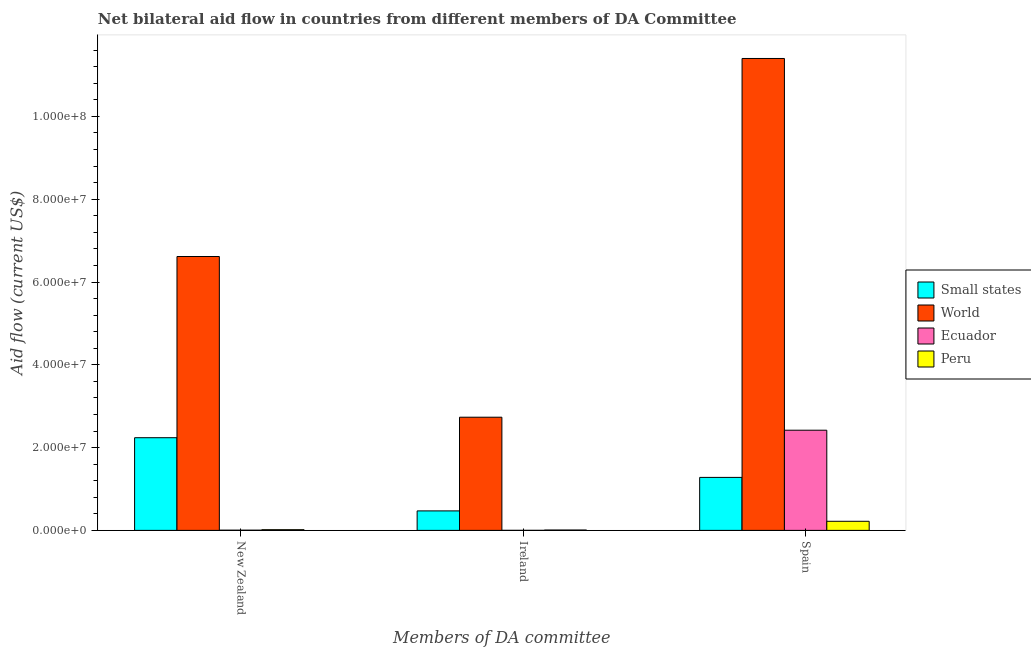Are the number of bars per tick equal to the number of legend labels?
Keep it short and to the point. Yes. Are the number of bars on each tick of the X-axis equal?
Provide a short and direct response. Yes. What is the label of the 2nd group of bars from the left?
Make the answer very short. Ireland. What is the amount of aid provided by ireland in Ecuador?
Offer a very short reply. 10000. Across all countries, what is the maximum amount of aid provided by spain?
Make the answer very short. 1.14e+08. Across all countries, what is the minimum amount of aid provided by ireland?
Your answer should be very brief. 10000. In which country was the amount of aid provided by new zealand maximum?
Keep it short and to the point. World. In which country was the amount of aid provided by new zealand minimum?
Ensure brevity in your answer.  Ecuador. What is the total amount of aid provided by spain in the graph?
Keep it short and to the point. 1.53e+08. What is the difference between the amount of aid provided by new zealand in Peru and that in World?
Your response must be concise. -6.60e+07. What is the difference between the amount of aid provided by new zealand in World and the amount of aid provided by ireland in Small states?
Offer a very short reply. 6.14e+07. What is the average amount of aid provided by spain per country?
Offer a terse response. 3.83e+07. What is the difference between the amount of aid provided by new zealand and amount of aid provided by spain in Peru?
Your answer should be compact. -2.03e+06. In how many countries, is the amount of aid provided by new zealand greater than 16000000 US$?
Your answer should be very brief. 2. What is the ratio of the amount of aid provided by new zealand in World to that in Peru?
Offer a terse response. 389.18. Is the amount of aid provided by spain in Peru less than that in Small states?
Keep it short and to the point. Yes. Is the difference between the amount of aid provided by spain in World and Small states greater than the difference between the amount of aid provided by ireland in World and Small states?
Your answer should be very brief. Yes. What is the difference between the highest and the second highest amount of aid provided by new zealand?
Ensure brevity in your answer.  4.38e+07. What is the difference between the highest and the lowest amount of aid provided by spain?
Make the answer very short. 1.12e+08. Is the sum of the amount of aid provided by ireland in Small states and Ecuador greater than the maximum amount of aid provided by new zealand across all countries?
Offer a very short reply. No. What does the 2nd bar from the left in Spain represents?
Offer a terse response. World. What does the 2nd bar from the right in New Zealand represents?
Ensure brevity in your answer.  Ecuador. How many bars are there?
Your answer should be compact. 12. Are all the bars in the graph horizontal?
Ensure brevity in your answer.  No. What is the difference between two consecutive major ticks on the Y-axis?
Offer a terse response. 2.00e+07. Are the values on the major ticks of Y-axis written in scientific E-notation?
Ensure brevity in your answer.  Yes. Where does the legend appear in the graph?
Provide a succinct answer. Center right. What is the title of the graph?
Your response must be concise. Net bilateral aid flow in countries from different members of DA Committee. What is the label or title of the X-axis?
Provide a short and direct response. Members of DA committee. What is the Aid flow (current US$) in Small states in New Zealand?
Your response must be concise. 2.24e+07. What is the Aid flow (current US$) of World in New Zealand?
Your response must be concise. 6.62e+07. What is the Aid flow (current US$) in Peru in New Zealand?
Ensure brevity in your answer.  1.70e+05. What is the Aid flow (current US$) in Small states in Ireland?
Give a very brief answer. 4.71e+06. What is the Aid flow (current US$) of World in Ireland?
Ensure brevity in your answer.  2.73e+07. What is the Aid flow (current US$) of Ecuador in Ireland?
Provide a short and direct response. 10000. What is the Aid flow (current US$) of Small states in Spain?
Offer a very short reply. 1.28e+07. What is the Aid flow (current US$) of World in Spain?
Make the answer very short. 1.14e+08. What is the Aid flow (current US$) of Ecuador in Spain?
Provide a short and direct response. 2.42e+07. What is the Aid flow (current US$) in Peru in Spain?
Your answer should be compact. 2.20e+06. Across all Members of DA committee, what is the maximum Aid flow (current US$) of Small states?
Provide a short and direct response. 2.24e+07. Across all Members of DA committee, what is the maximum Aid flow (current US$) of World?
Your answer should be very brief. 1.14e+08. Across all Members of DA committee, what is the maximum Aid flow (current US$) of Ecuador?
Ensure brevity in your answer.  2.42e+07. Across all Members of DA committee, what is the maximum Aid flow (current US$) in Peru?
Provide a succinct answer. 2.20e+06. Across all Members of DA committee, what is the minimum Aid flow (current US$) of Small states?
Offer a very short reply. 4.71e+06. Across all Members of DA committee, what is the minimum Aid flow (current US$) in World?
Your response must be concise. 2.73e+07. Across all Members of DA committee, what is the minimum Aid flow (current US$) of Peru?
Your answer should be compact. 9.00e+04. What is the total Aid flow (current US$) in Small states in the graph?
Provide a short and direct response. 3.99e+07. What is the total Aid flow (current US$) of World in the graph?
Ensure brevity in your answer.  2.08e+08. What is the total Aid flow (current US$) in Ecuador in the graph?
Your answer should be very brief. 2.43e+07. What is the total Aid flow (current US$) of Peru in the graph?
Provide a short and direct response. 2.46e+06. What is the difference between the Aid flow (current US$) of Small states in New Zealand and that in Ireland?
Keep it short and to the point. 1.77e+07. What is the difference between the Aid flow (current US$) of World in New Zealand and that in Ireland?
Provide a succinct answer. 3.88e+07. What is the difference between the Aid flow (current US$) of Peru in New Zealand and that in Ireland?
Offer a terse response. 8.00e+04. What is the difference between the Aid flow (current US$) of Small states in New Zealand and that in Spain?
Provide a succinct answer. 9.59e+06. What is the difference between the Aid flow (current US$) of World in New Zealand and that in Spain?
Provide a short and direct response. -4.78e+07. What is the difference between the Aid flow (current US$) of Ecuador in New Zealand and that in Spain?
Offer a very short reply. -2.42e+07. What is the difference between the Aid flow (current US$) of Peru in New Zealand and that in Spain?
Make the answer very short. -2.03e+06. What is the difference between the Aid flow (current US$) of Small states in Ireland and that in Spain?
Your answer should be compact. -8.09e+06. What is the difference between the Aid flow (current US$) of World in Ireland and that in Spain?
Offer a terse response. -8.67e+07. What is the difference between the Aid flow (current US$) in Ecuador in Ireland and that in Spain?
Make the answer very short. -2.42e+07. What is the difference between the Aid flow (current US$) in Peru in Ireland and that in Spain?
Give a very brief answer. -2.11e+06. What is the difference between the Aid flow (current US$) of Small states in New Zealand and the Aid flow (current US$) of World in Ireland?
Give a very brief answer. -4.95e+06. What is the difference between the Aid flow (current US$) of Small states in New Zealand and the Aid flow (current US$) of Ecuador in Ireland?
Give a very brief answer. 2.24e+07. What is the difference between the Aid flow (current US$) in Small states in New Zealand and the Aid flow (current US$) in Peru in Ireland?
Your answer should be very brief. 2.23e+07. What is the difference between the Aid flow (current US$) of World in New Zealand and the Aid flow (current US$) of Ecuador in Ireland?
Offer a very short reply. 6.62e+07. What is the difference between the Aid flow (current US$) in World in New Zealand and the Aid flow (current US$) in Peru in Ireland?
Ensure brevity in your answer.  6.61e+07. What is the difference between the Aid flow (current US$) of Ecuador in New Zealand and the Aid flow (current US$) of Peru in Ireland?
Provide a succinct answer. -4.00e+04. What is the difference between the Aid flow (current US$) in Small states in New Zealand and the Aid flow (current US$) in World in Spain?
Offer a very short reply. -9.16e+07. What is the difference between the Aid flow (current US$) of Small states in New Zealand and the Aid flow (current US$) of Ecuador in Spain?
Your answer should be very brief. -1.81e+06. What is the difference between the Aid flow (current US$) of Small states in New Zealand and the Aid flow (current US$) of Peru in Spain?
Give a very brief answer. 2.02e+07. What is the difference between the Aid flow (current US$) in World in New Zealand and the Aid flow (current US$) in Ecuador in Spain?
Give a very brief answer. 4.20e+07. What is the difference between the Aid flow (current US$) of World in New Zealand and the Aid flow (current US$) of Peru in Spain?
Offer a terse response. 6.40e+07. What is the difference between the Aid flow (current US$) in Ecuador in New Zealand and the Aid flow (current US$) in Peru in Spain?
Your answer should be compact. -2.15e+06. What is the difference between the Aid flow (current US$) of Small states in Ireland and the Aid flow (current US$) of World in Spain?
Offer a very short reply. -1.09e+08. What is the difference between the Aid flow (current US$) in Small states in Ireland and the Aid flow (current US$) in Ecuador in Spain?
Your answer should be compact. -1.95e+07. What is the difference between the Aid flow (current US$) in Small states in Ireland and the Aid flow (current US$) in Peru in Spain?
Give a very brief answer. 2.51e+06. What is the difference between the Aid flow (current US$) of World in Ireland and the Aid flow (current US$) of Ecuador in Spain?
Keep it short and to the point. 3.14e+06. What is the difference between the Aid flow (current US$) of World in Ireland and the Aid flow (current US$) of Peru in Spain?
Ensure brevity in your answer.  2.51e+07. What is the difference between the Aid flow (current US$) in Ecuador in Ireland and the Aid flow (current US$) in Peru in Spain?
Your response must be concise. -2.19e+06. What is the average Aid flow (current US$) of Small states per Members of DA committee?
Your response must be concise. 1.33e+07. What is the average Aid flow (current US$) of World per Members of DA committee?
Offer a terse response. 6.92e+07. What is the average Aid flow (current US$) of Ecuador per Members of DA committee?
Provide a short and direct response. 8.09e+06. What is the average Aid flow (current US$) in Peru per Members of DA committee?
Ensure brevity in your answer.  8.20e+05. What is the difference between the Aid flow (current US$) in Small states and Aid flow (current US$) in World in New Zealand?
Give a very brief answer. -4.38e+07. What is the difference between the Aid flow (current US$) in Small states and Aid flow (current US$) in Ecuador in New Zealand?
Provide a short and direct response. 2.23e+07. What is the difference between the Aid flow (current US$) in Small states and Aid flow (current US$) in Peru in New Zealand?
Make the answer very short. 2.22e+07. What is the difference between the Aid flow (current US$) in World and Aid flow (current US$) in Ecuador in New Zealand?
Provide a short and direct response. 6.61e+07. What is the difference between the Aid flow (current US$) in World and Aid flow (current US$) in Peru in New Zealand?
Provide a succinct answer. 6.60e+07. What is the difference between the Aid flow (current US$) in Small states and Aid flow (current US$) in World in Ireland?
Ensure brevity in your answer.  -2.26e+07. What is the difference between the Aid flow (current US$) of Small states and Aid flow (current US$) of Ecuador in Ireland?
Provide a succinct answer. 4.70e+06. What is the difference between the Aid flow (current US$) in Small states and Aid flow (current US$) in Peru in Ireland?
Ensure brevity in your answer.  4.62e+06. What is the difference between the Aid flow (current US$) in World and Aid flow (current US$) in Ecuador in Ireland?
Ensure brevity in your answer.  2.73e+07. What is the difference between the Aid flow (current US$) in World and Aid flow (current US$) in Peru in Ireland?
Offer a very short reply. 2.72e+07. What is the difference between the Aid flow (current US$) in Ecuador and Aid flow (current US$) in Peru in Ireland?
Your answer should be very brief. -8.00e+04. What is the difference between the Aid flow (current US$) in Small states and Aid flow (current US$) in World in Spain?
Your answer should be very brief. -1.01e+08. What is the difference between the Aid flow (current US$) of Small states and Aid flow (current US$) of Ecuador in Spain?
Your answer should be compact. -1.14e+07. What is the difference between the Aid flow (current US$) of Small states and Aid flow (current US$) of Peru in Spain?
Your response must be concise. 1.06e+07. What is the difference between the Aid flow (current US$) of World and Aid flow (current US$) of Ecuador in Spain?
Keep it short and to the point. 8.98e+07. What is the difference between the Aid flow (current US$) of World and Aid flow (current US$) of Peru in Spain?
Offer a very short reply. 1.12e+08. What is the difference between the Aid flow (current US$) of Ecuador and Aid flow (current US$) of Peru in Spain?
Keep it short and to the point. 2.20e+07. What is the ratio of the Aid flow (current US$) in Small states in New Zealand to that in Ireland?
Offer a very short reply. 4.75. What is the ratio of the Aid flow (current US$) of World in New Zealand to that in Ireland?
Provide a succinct answer. 2.42. What is the ratio of the Aid flow (current US$) in Ecuador in New Zealand to that in Ireland?
Give a very brief answer. 5. What is the ratio of the Aid flow (current US$) in Peru in New Zealand to that in Ireland?
Provide a succinct answer. 1.89. What is the ratio of the Aid flow (current US$) of Small states in New Zealand to that in Spain?
Make the answer very short. 1.75. What is the ratio of the Aid flow (current US$) in World in New Zealand to that in Spain?
Ensure brevity in your answer.  0.58. What is the ratio of the Aid flow (current US$) in Ecuador in New Zealand to that in Spain?
Make the answer very short. 0. What is the ratio of the Aid flow (current US$) in Peru in New Zealand to that in Spain?
Your response must be concise. 0.08. What is the ratio of the Aid flow (current US$) of Small states in Ireland to that in Spain?
Offer a terse response. 0.37. What is the ratio of the Aid flow (current US$) in World in Ireland to that in Spain?
Your response must be concise. 0.24. What is the ratio of the Aid flow (current US$) of Peru in Ireland to that in Spain?
Your response must be concise. 0.04. What is the difference between the highest and the second highest Aid flow (current US$) in Small states?
Provide a succinct answer. 9.59e+06. What is the difference between the highest and the second highest Aid flow (current US$) in World?
Give a very brief answer. 4.78e+07. What is the difference between the highest and the second highest Aid flow (current US$) in Ecuador?
Offer a terse response. 2.42e+07. What is the difference between the highest and the second highest Aid flow (current US$) of Peru?
Give a very brief answer. 2.03e+06. What is the difference between the highest and the lowest Aid flow (current US$) of Small states?
Provide a succinct answer. 1.77e+07. What is the difference between the highest and the lowest Aid flow (current US$) in World?
Provide a short and direct response. 8.67e+07. What is the difference between the highest and the lowest Aid flow (current US$) of Ecuador?
Give a very brief answer. 2.42e+07. What is the difference between the highest and the lowest Aid flow (current US$) of Peru?
Provide a succinct answer. 2.11e+06. 